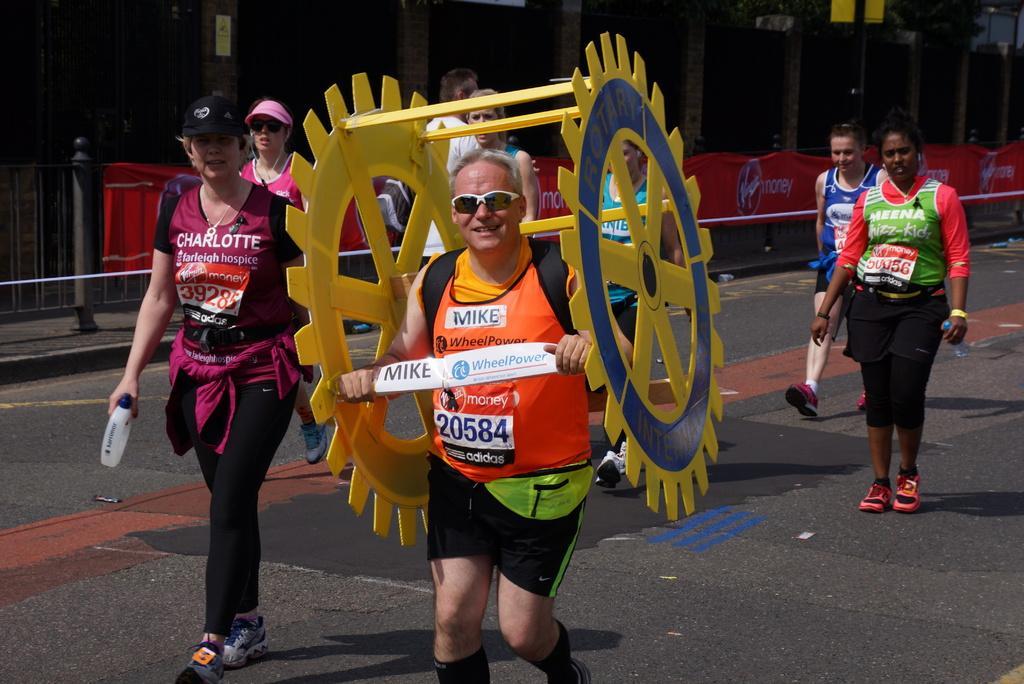Please provide a concise description of this image. In this image there are group of people walking on the road in which one of them is holding a wheel, beside them there is a building and fence in front of that. 